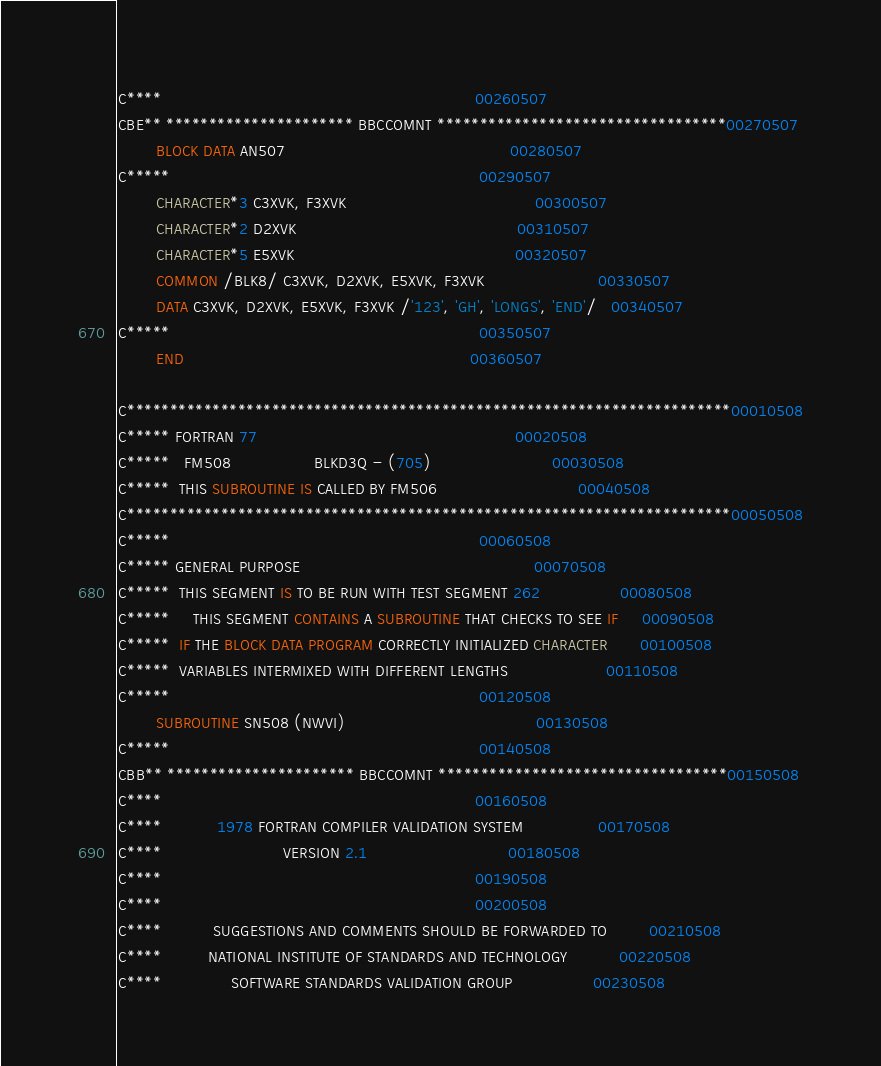<code> <loc_0><loc_0><loc_500><loc_500><_FORTRAN_>C****                                                                   00260507
CBE** ********************** BBCCOMNT **********************************00270507
        BLOCK DATA AN507                                                00280507
C*****                                                                  00290507
        CHARACTER*3 C3XVK, F3XVK                                        00300507
        CHARACTER*2 D2XVK                                               00310507
        CHARACTER*5 E5XVK                                               00320507
        COMMON /BLK8/ C3XVK, D2XVK, E5XVK, F3XVK                        00330507
        DATA C3XVK, D2XVK, E5XVK, F3XVK /'123', 'GH', 'LONGS', 'END'/   00340507
C*****                                                                  00350507
        END                                                             00360507

C***********************************************************************00010508
C***** FORTRAN 77                                                       00020508
C*****   FM508                  BLKD3Q - (705)                          00030508
C*****  THIS SUBROUTINE IS CALLED BY FM506                              00040508
C***********************************************************************00050508
C*****                                                                  00060508
C***** GENERAL PURPOSE                                                  00070508
C*****  THIS SEGMENT IS TO BE RUN WITH TEST SEGMENT 262                 00080508
C*****     THIS SEGMENT CONTAINS A SUBROUTINE THAT CHECKS TO SEE IF     00090508
C*****  IF THE BLOCK DATA PROGRAM CORRECTLY INITIALIZED CHARACTER       00100508
C*****  VARIABLES INTERMIXED WITH DIFFERENT LENGTHS                     00110508
C*****                                                                  00120508
        SUBROUTINE SN508 (NWVI)                                         00130508
C*****                                                                  00140508
CBB** ********************** BBCCOMNT **********************************00150508
C****                                                                   00160508
C****            1978 FORTRAN COMPILER VALIDATION SYSTEM                00170508
C****                          VERSION 2.1                              00180508
C****                                                                   00190508
C****                                                                   00200508
C****           SUGGESTIONS AND COMMENTS SHOULD BE FORWARDED TO         00210508
C****          NATIONAL INSTITUTE OF STANDARDS AND TECHNOLOGY           00220508
C****               SOFTWARE STANDARDS VALIDATION GROUP                 00230508</code> 